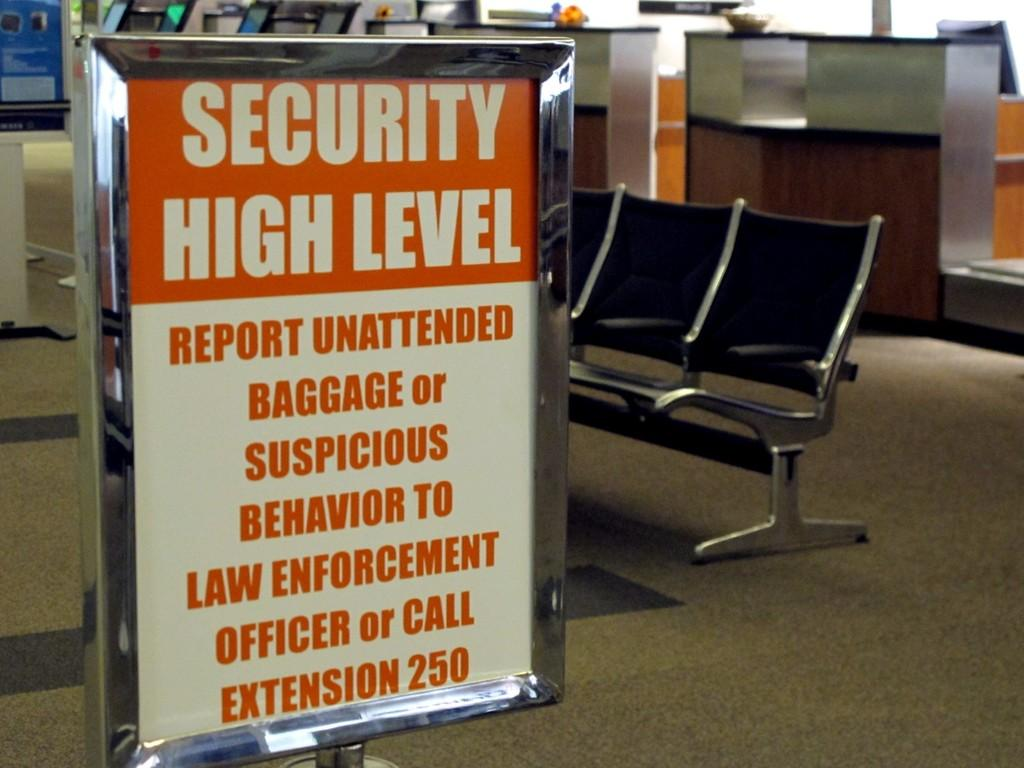<image>
Describe the image concisely. Sign that says there is high levels of security. 